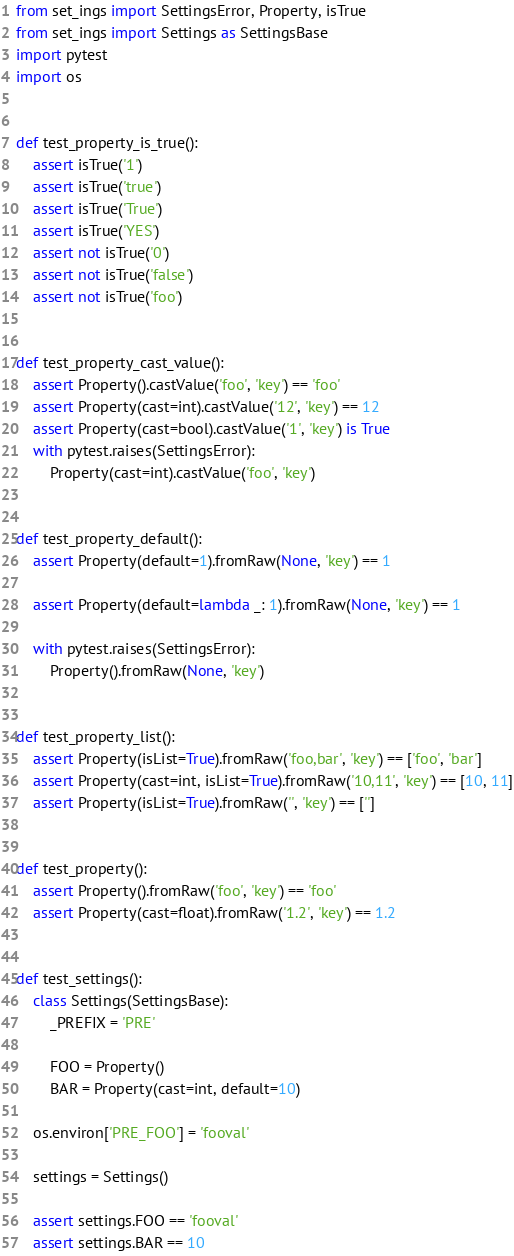Convert code to text. <code><loc_0><loc_0><loc_500><loc_500><_Python_>from set_ings import SettingsError, Property, isTrue
from set_ings import Settings as SettingsBase
import pytest
import os


def test_property_is_true():
    assert isTrue('1')
    assert isTrue('true')
    assert isTrue('True')
    assert isTrue('YES')
    assert not isTrue('0')
    assert not isTrue('false')
    assert not isTrue('foo')


def test_property_cast_value():
    assert Property().castValue('foo', 'key') == 'foo'
    assert Property(cast=int).castValue('12', 'key') == 12
    assert Property(cast=bool).castValue('1', 'key') is True
    with pytest.raises(SettingsError):
        Property(cast=int).castValue('foo', 'key')


def test_property_default():
    assert Property(default=1).fromRaw(None, 'key') == 1

    assert Property(default=lambda _: 1).fromRaw(None, 'key') == 1

    with pytest.raises(SettingsError):
        Property().fromRaw(None, 'key')


def test_property_list():
    assert Property(isList=True).fromRaw('foo,bar', 'key') == ['foo', 'bar']
    assert Property(cast=int, isList=True).fromRaw('10,11', 'key') == [10, 11]
    assert Property(isList=True).fromRaw('', 'key') == ['']


def test_property():
    assert Property().fromRaw('foo', 'key') == 'foo'
    assert Property(cast=float).fromRaw('1.2', 'key') == 1.2


def test_settings():
    class Settings(SettingsBase):
        _PREFIX = 'PRE'

        FOO = Property()
        BAR = Property(cast=int, default=10)

    os.environ['PRE_FOO'] = 'fooval'

    settings = Settings()

    assert settings.FOO == 'fooval'
    assert settings.BAR == 10
</code> 